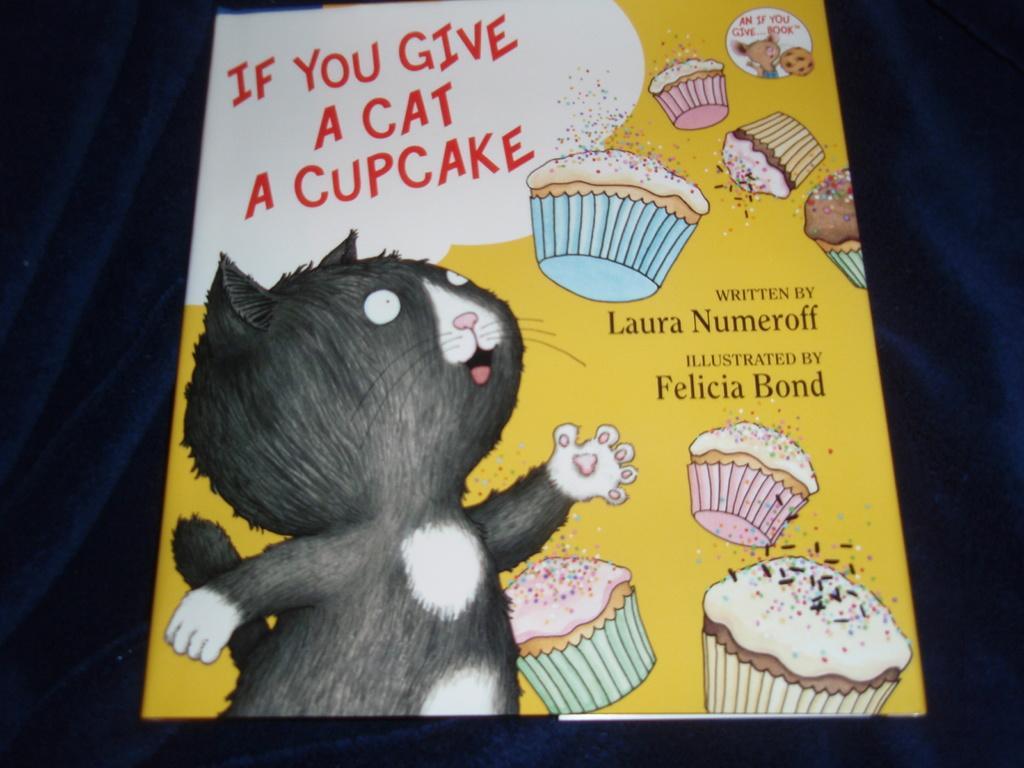How would you summarize this image in a sentence or two? In this image I can see a cartoon image of a cat and food items on a yellow color board. I can also see something written on this object. The background of the image is dark. 